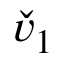Convert formula to latex. <formula><loc_0><loc_0><loc_500><loc_500>\check { v } _ { 1 }</formula> 